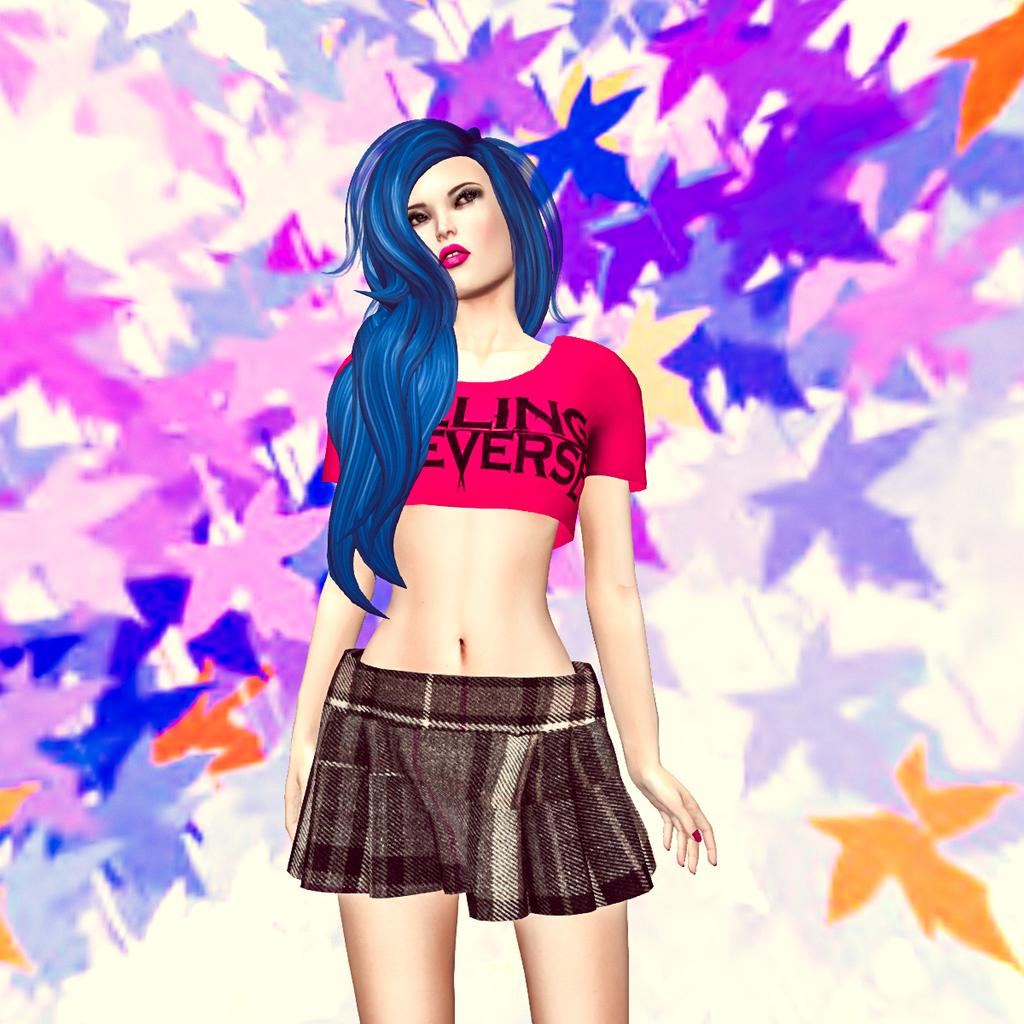Provide a one-sentence caption for the provided image. Blue hair covers a shirt that appears to say ling everse. 